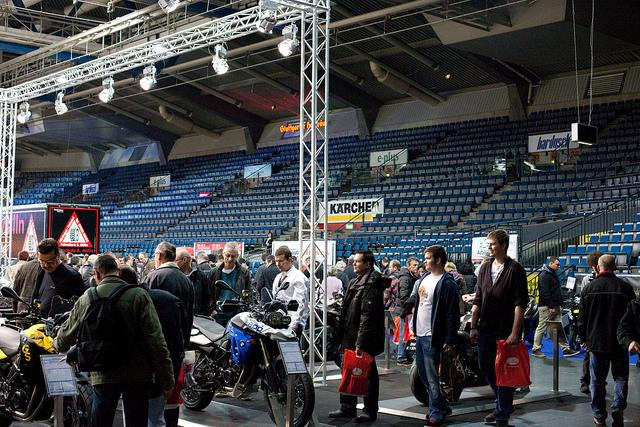What type of vehicle are the people looking at? Please explain your reasoning. motorcycle. Motorcycles are on display. people are gathered all around. 